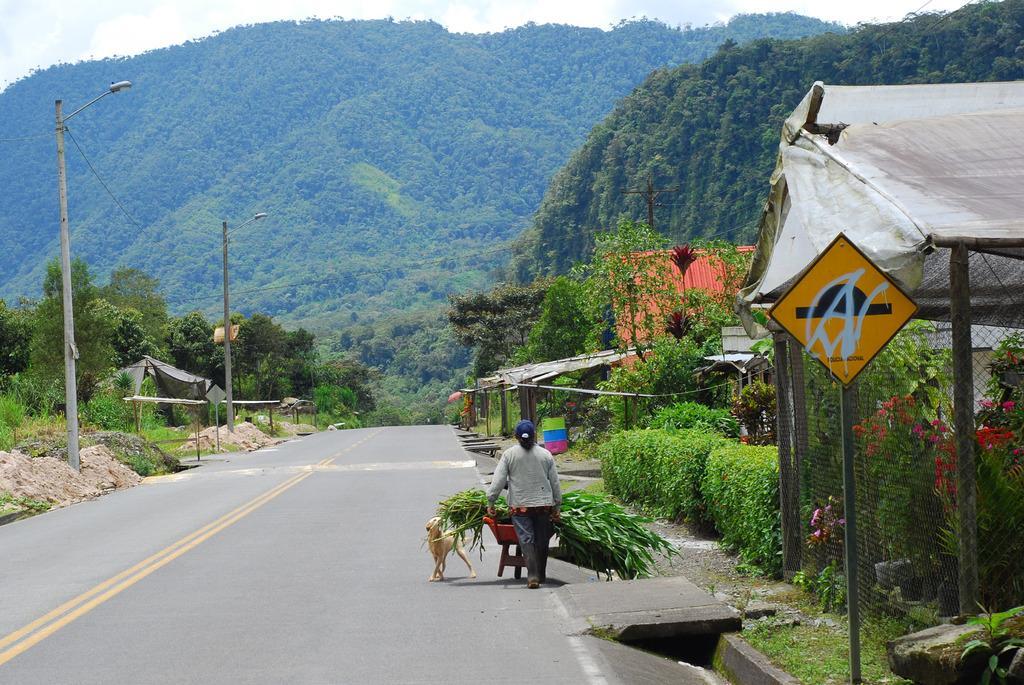Could you give a brief overview of what you see in this image? In this image, we can see a person and an animal. We can see a trolley with some objects. We can see some grass, plants, trees, poles, sheds, hills and boards. We can see the ground and the sky. 